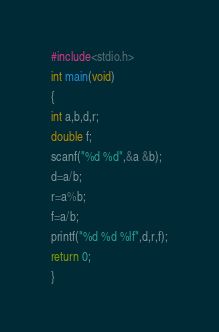Convert code to text. <code><loc_0><loc_0><loc_500><loc_500><_C_>#include<stdio.h>

int main(void)

{

int a,b,d,r;

double f;

scanf("%d %d",&a &b);

d=a/b;

r=a%b;

f=a/b;

printf("%d %d %lf",d,r,f);

return 0;

}</code> 